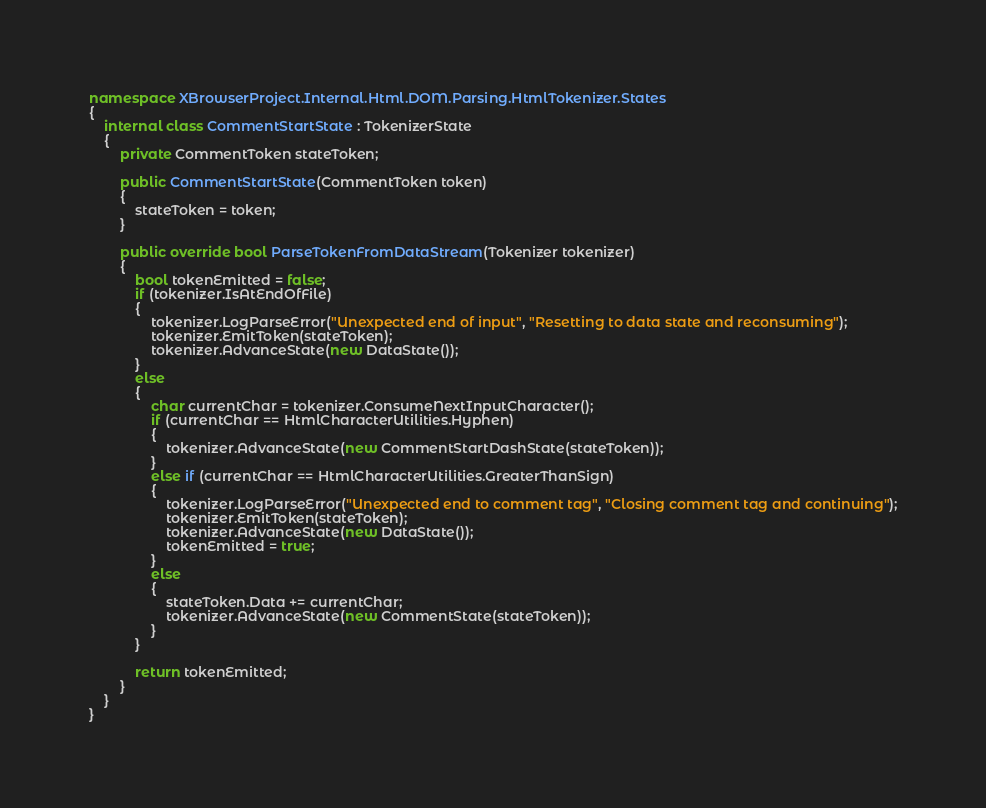Convert code to text. <code><loc_0><loc_0><loc_500><loc_500><_C#_>namespace XBrowserProject.Internal.Html.DOM.Parsing.HtmlTokenizer.States
{
    internal class CommentStartState : TokenizerState
    {
        private CommentToken stateToken;

        public CommentStartState(CommentToken token)
        {
            stateToken = token;
        }

        public override bool ParseTokenFromDataStream(Tokenizer tokenizer)
        {
            bool tokenEmitted = false;
            if (tokenizer.IsAtEndOfFile)
            {
                tokenizer.LogParseError("Unexpected end of input", "Resetting to data state and reconsuming");
                tokenizer.EmitToken(stateToken);
                tokenizer.AdvanceState(new DataState());
            }
            else
            {
                char currentChar = tokenizer.ConsumeNextInputCharacter();
                if (currentChar == HtmlCharacterUtilities.Hyphen)
                {
                    tokenizer.AdvanceState(new CommentStartDashState(stateToken));
                }
                else if (currentChar == HtmlCharacterUtilities.GreaterThanSign)
                {
                    tokenizer.LogParseError("Unexpected end to comment tag", "Closing comment tag and continuing");
                    tokenizer.EmitToken(stateToken);
                    tokenizer.AdvanceState(new DataState());
                    tokenEmitted = true;
                }
                else
                {
                    stateToken.Data += currentChar;
                    tokenizer.AdvanceState(new CommentState(stateToken));
                }
            }

            return tokenEmitted;
        }
    }
}
</code> 